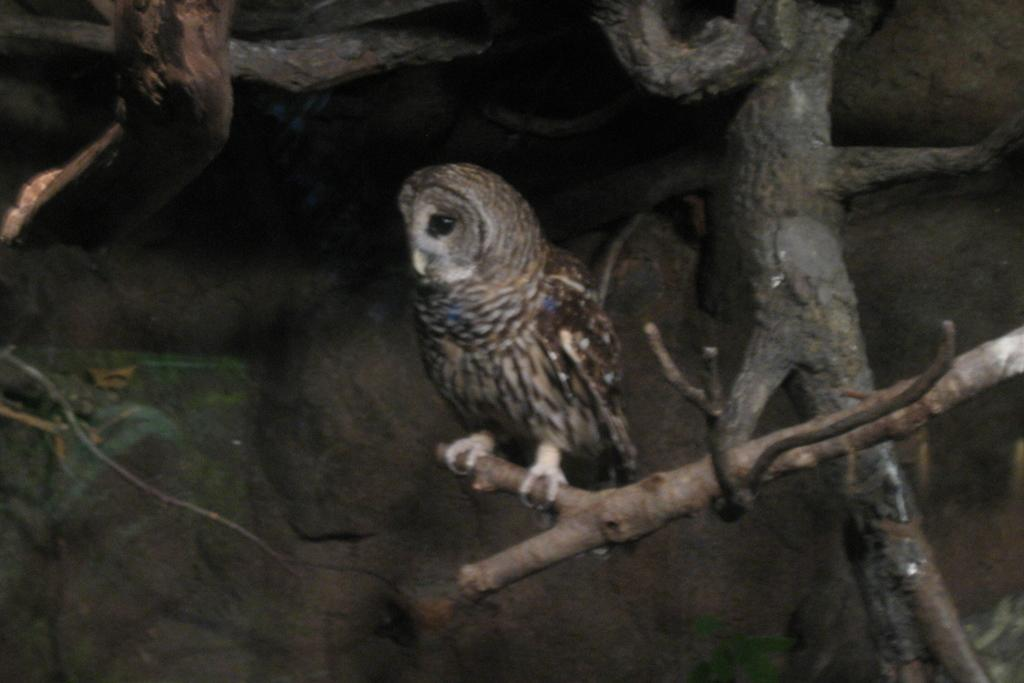What type of animal can be seen in the image? There is a bird in the image. What colors are present on the bird? The bird is in brown and ash colors. Where is the bird located in the image? The bird is on a tree branch. What other object can be seen in the background of the image? There is a rock visible in the background of the image. How does the bird help the kitten in the image? There is no kitten present in the image, so the bird cannot help a kitten. 